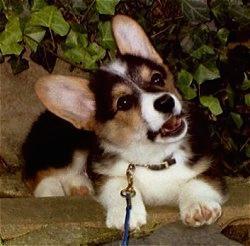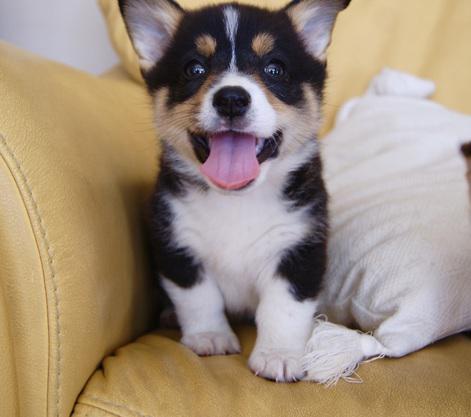The first image is the image on the left, the second image is the image on the right. Considering the images on both sides, is "A small dog with its tongue hanging out is on a light colored chair." valid? Answer yes or no. Yes. The first image is the image on the left, the second image is the image on the right. Examine the images to the left and right. Is the description "One puppy has their tongue out." accurate? Answer yes or no. Yes. 